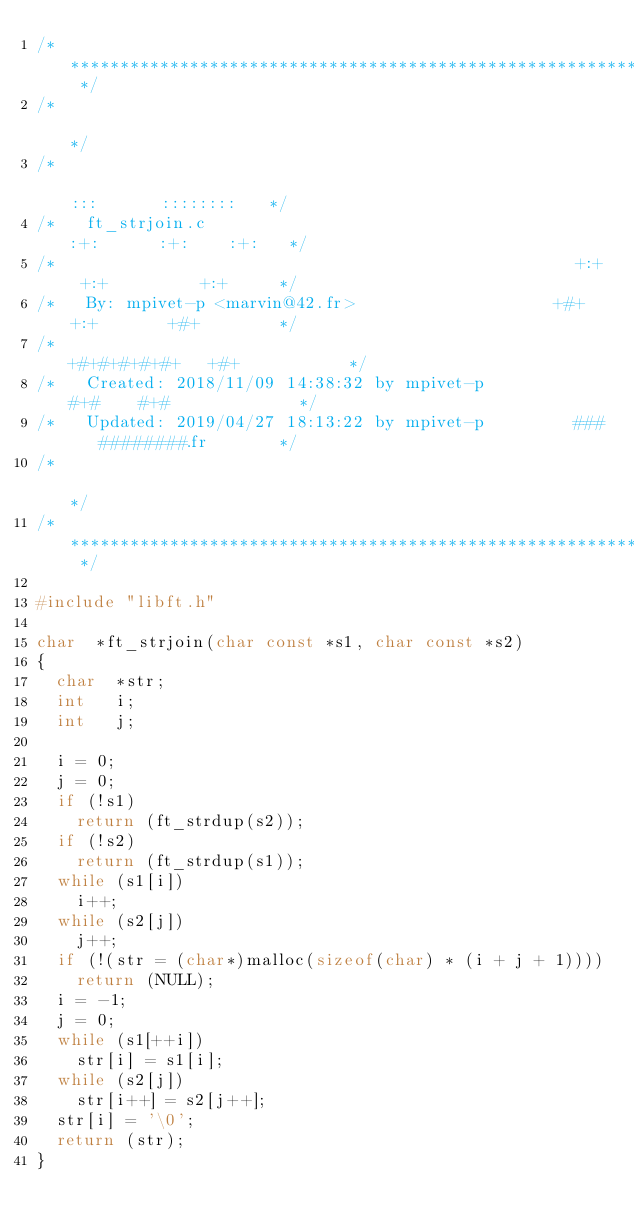Convert code to text. <code><loc_0><loc_0><loc_500><loc_500><_C_>/* ************************************************************************** */
/*                                                                            */
/*                                                        :::      ::::::::   */
/*   ft_strjoin.c                                       :+:      :+:    :+:   */
/*                                                    +:+ +:+         +:+     */
/*   By: mpivet-p <marvin@42.fr>                    +#+  +:+       +#+        */
/*                                                +#+#+#+#+#+   +#+           */
/*   Created: 2018/11/09 14:38:32 by mpivet-p          #+#    #+#             */
/*   Updated: 2019/04/27 18:13:22 by mpivet-p         ###   ########.fr       */
/*                                                                            */
/* ************************************************************************** */

#include "libft.h"

char	*ft_strjoin(char const *s1, char const *s2)
{
	char	*str;
	int		i;
	int		j;

	i = 0;
	j = 0;
	if (!s1)
		return (ft_strdup(s2));
	if (!s2)
		return (ft_strdup(s1));
	while (s1[i])
		i++;
	while (s2[j])
		j++;
	if (!(str = (char*)malloc(sizeof(char) * (i + j + 1))))
		return (NULL);
	i = -1;
	j = 0;
	while (s1[++i])
		str[i] = s1[i];
	while (s2[j])
		str[i++] = s2[j++];
	str[i] = '\0';
	return (str);
}
</code> 